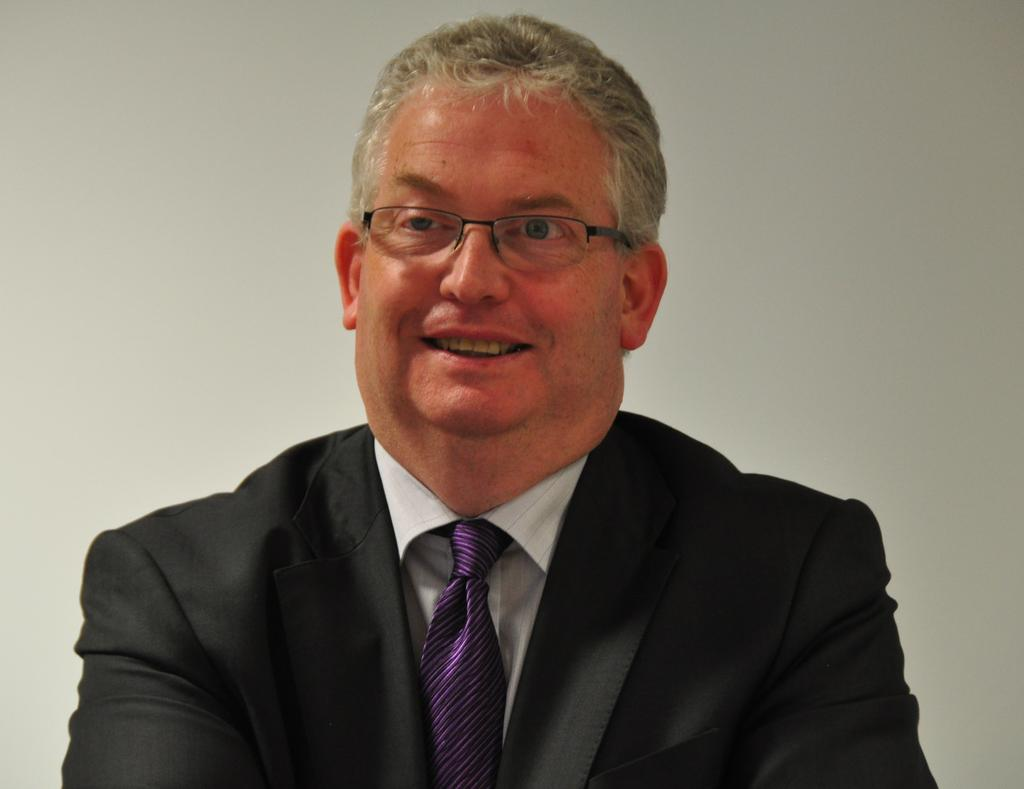What is the main subject of the image? There is a person in the image. What is the person wearing on their upper body? The person is wearing a black blazer. What type of accessory is the person wearing around their neck? The person is wearing a violet tie. What type of eyewear is the person wearing? The person is wearing white-colored specs. What can be seen in the background of the image? There is a white wall in the background of the image. Are there any trees visible in the image? There are no trees present in the image; it features a person standing in front of a white wall. What type of plantation can be seen in the background of the image? There is no plantation visible in the image; it features a person standing in front of a white wall. 